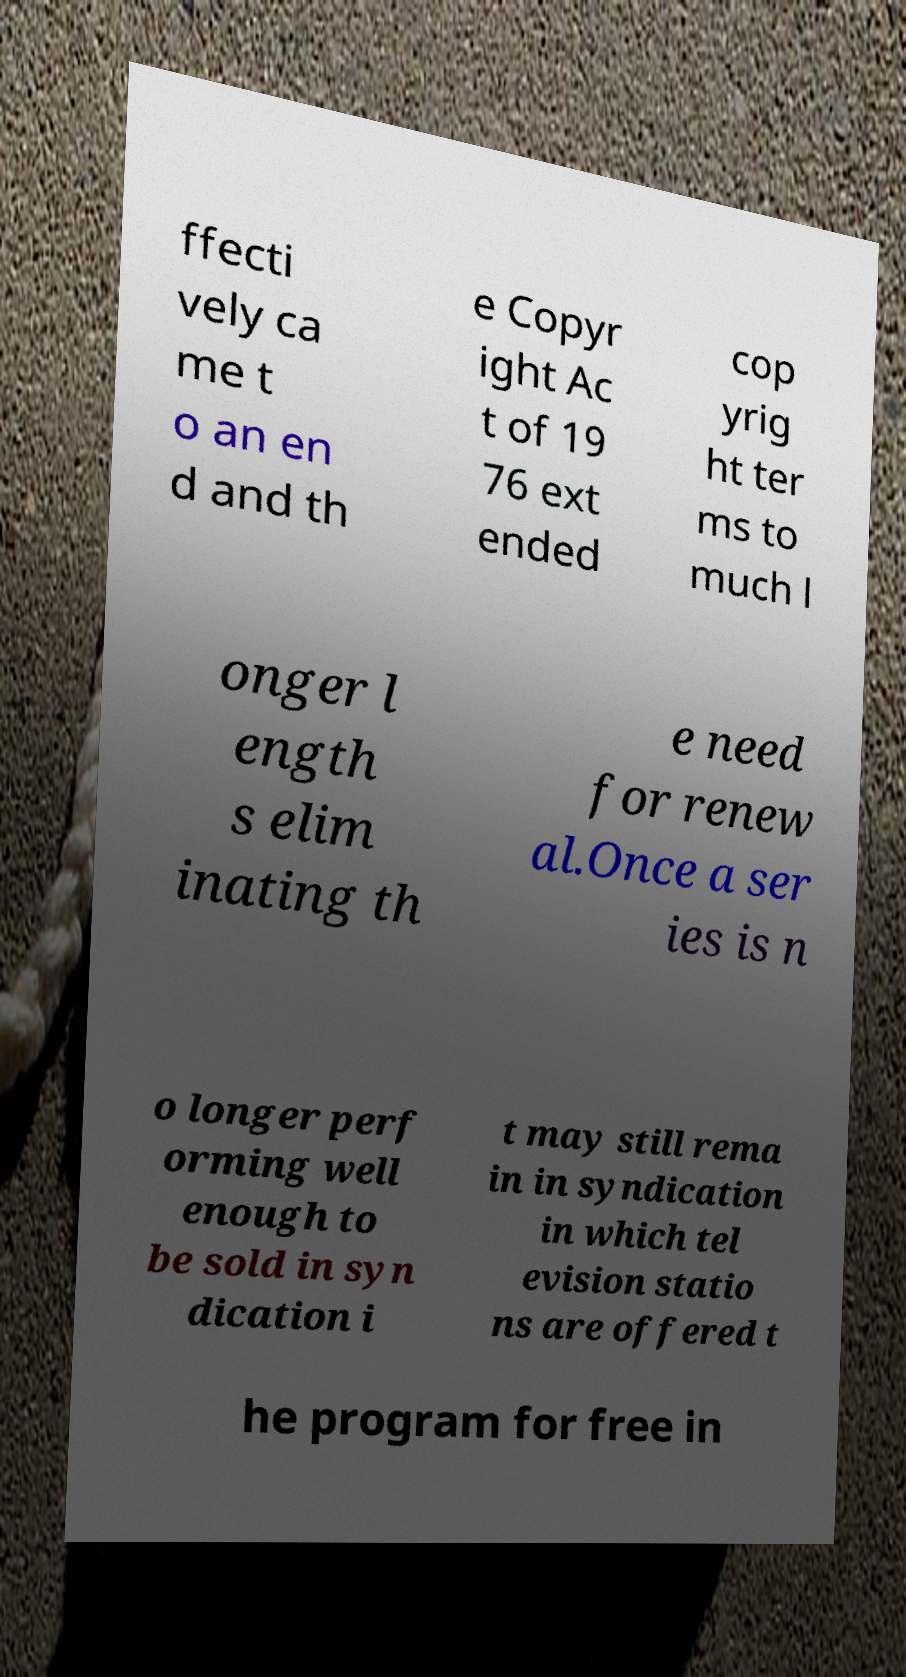Please identify and transcribe the text found in this image. ffecti vely ca me t o an en d and th e Copyr ight Ac t of 19 76 ext ended cop yrig ht ter ms to much l onger l ength s elim inating th e need for renew al.Once a ser ies is n o longer perf orming well enough to be sold in syn dication i t may still rema in in syndication in which tel evision statio ns are offered t he program for free in 